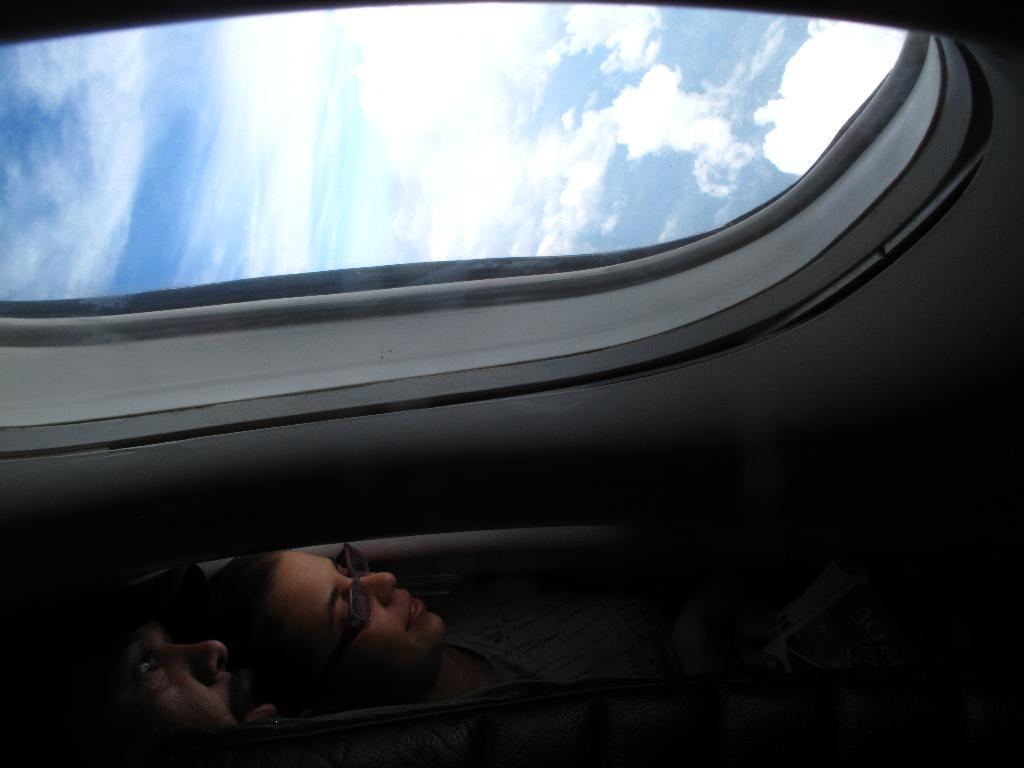How many people are in the image? There are two people in the image. What is the perspective of the image? The image appears to be taken from a vehicle. What type of structure is visible in the image? There is a window with a glass door in the image. What can be seen in the background of the image? The sky is visible in the image, and clouds are present in the sky. What type of insurance policy is being discussed by the people in the image? There is no indication in the image that the people are discussing any insurance policies. Can you tell me which page of the book the people are reading in the image? There is no book present in the image, so it is not possible to determine which page they might be reading. 